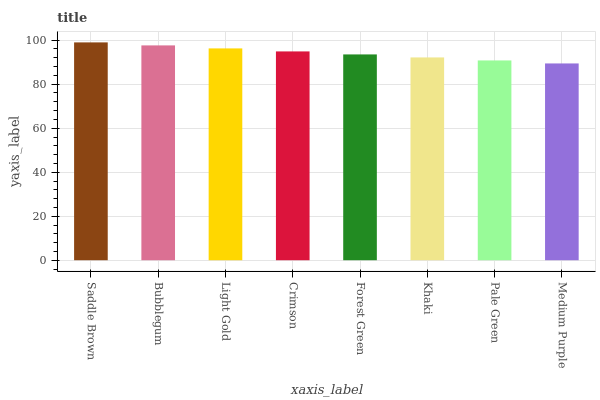Is Medium Purple the minimum?
Answer yes or no. Yes. Is Saddle Brown the maximum?
Answer yes or no. Yes. Is Bubblegum the minimum?
Answer yes or no. No. Is Bubblegum the maximum?
Answer yes or no. No. Is Saddle Brown greater than Bubblegum?
Answer yes or no. Yes. Is Bubblegum less than Saddle Brown?
Answer yes or no. Yes. Is Bubblegum greater than Saddle Brown?
Answer yes or no. No. Is Saddle Brown less than Bubblegum?
Answer yes or no. No. Is Crimson the high median?
Answer yes or no. Yes. Is Forest Green the low median?
Answer yes or no. Yes. Is Khaki the high median?
Answer yes or no. No. Is Khaki the low median?
Answer yes or no. No. 